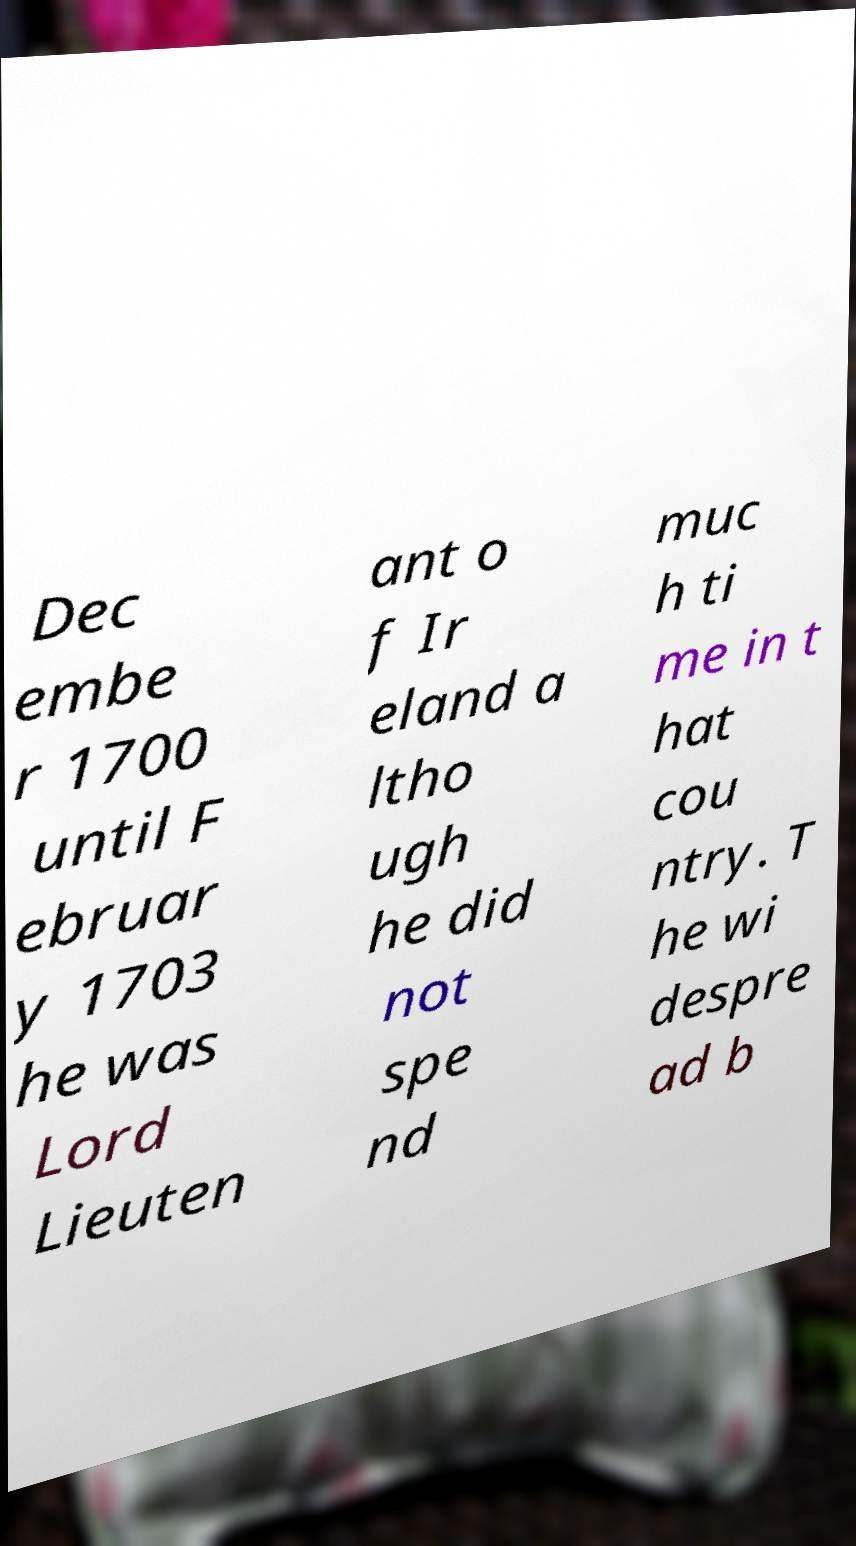There's text embedded in this image that I need extracted. Can you transcribe it verbatim? Dec embe r 1700 until F ebruar y 1703 he was Lord Lieuten ant o f Ir eland a ltho ugh he did not spe nd muc h ti me in t hat cou ntry. T he wi despre ad b 